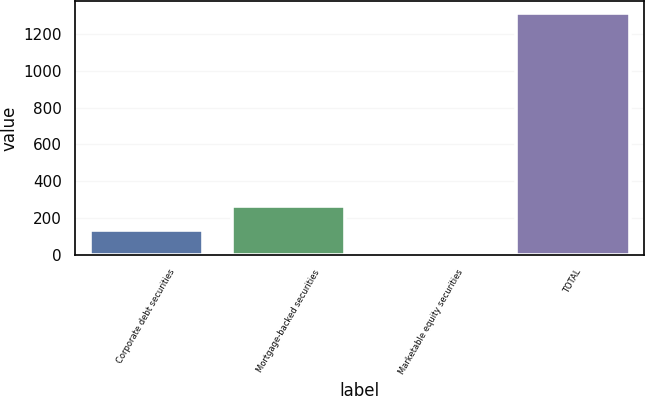Convert chart. <chart><loc_0><loc_0><loc_500><loc_500><bar_chart><fcel>Corporate debt securities<fcel>Mortgage-backed securities<fcel>Marketable equity securities<fcel>TOTAL<nl><fcel>133<fcel>264<fcel>2<fcel>1312<nl></chart> 